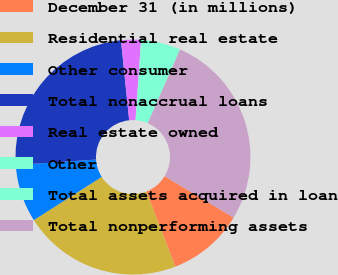Convert chart. <chart><loc_0><loc_0><loc_500><loc_500><pie_chart><fcel>December 31 (in millions)<fcel>Residential real estate<fcel>Other consumer<fcel>Total nonaccrual loans<fcel>Real estate owned<fcel>Other<fcel>Total assets acquired in loan<fcel>Total nonperforming assets<nl><fcel>10.52%<fcel>21.85%<fcel>7.93%<fcel>24.45%<fcel>2.73%<fcel>0.13%<fcel>5.33%<fcel>27.05%<nl></chart> 